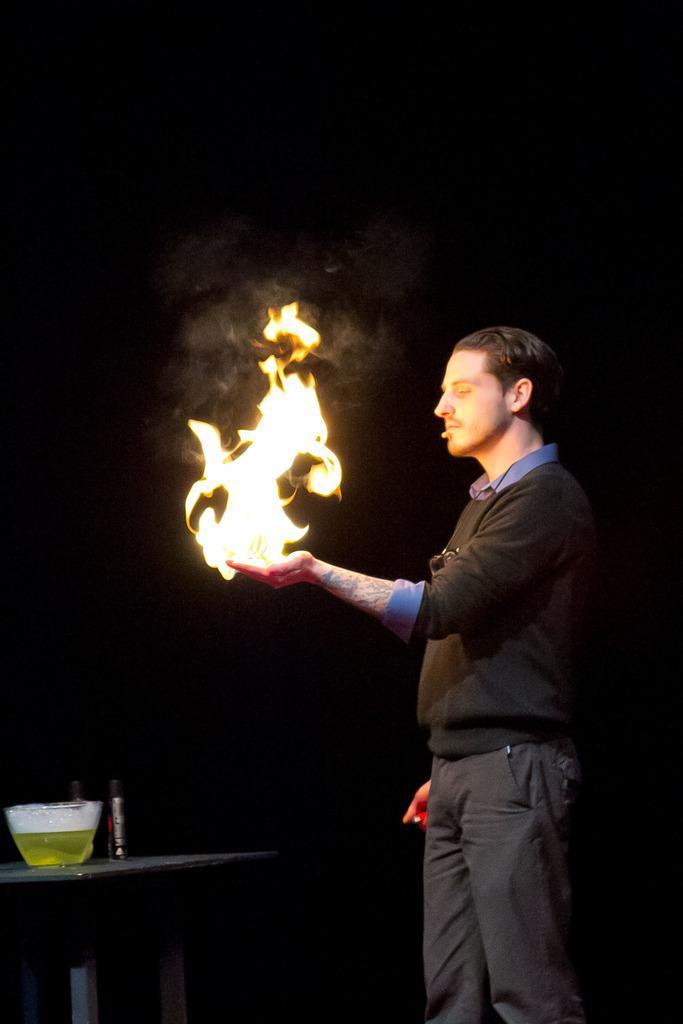Describe this image in one or two sentences. In this image on the right, there is a man, he wears a t shirt, trouser, he is holding fire. On the left there is a table on that there is a bowl and bottle. 